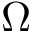<formula> <loc_0><loc_0><loc_500><loc_500>\Omega</formula> 